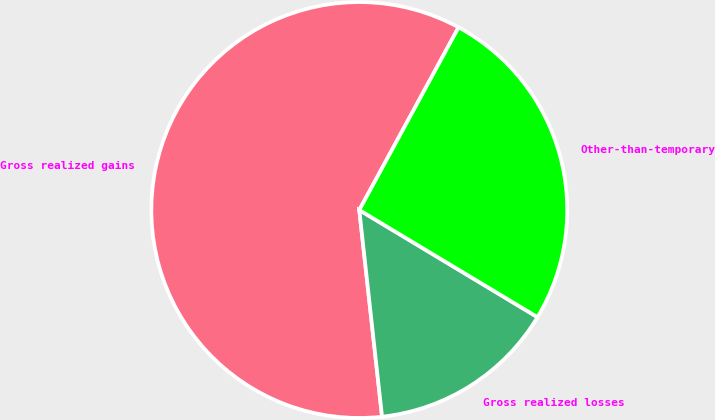Convert chart. <chart><loc_0><loc_0><loc_500><loc_500><pie_chart><fcel>Gross realized gains<fcel>Gross realized losses<fcel>Other-than-temporary<nl><fcel>59.67%<fcel>14.64%<fcel>25.69%<nl></chart> 